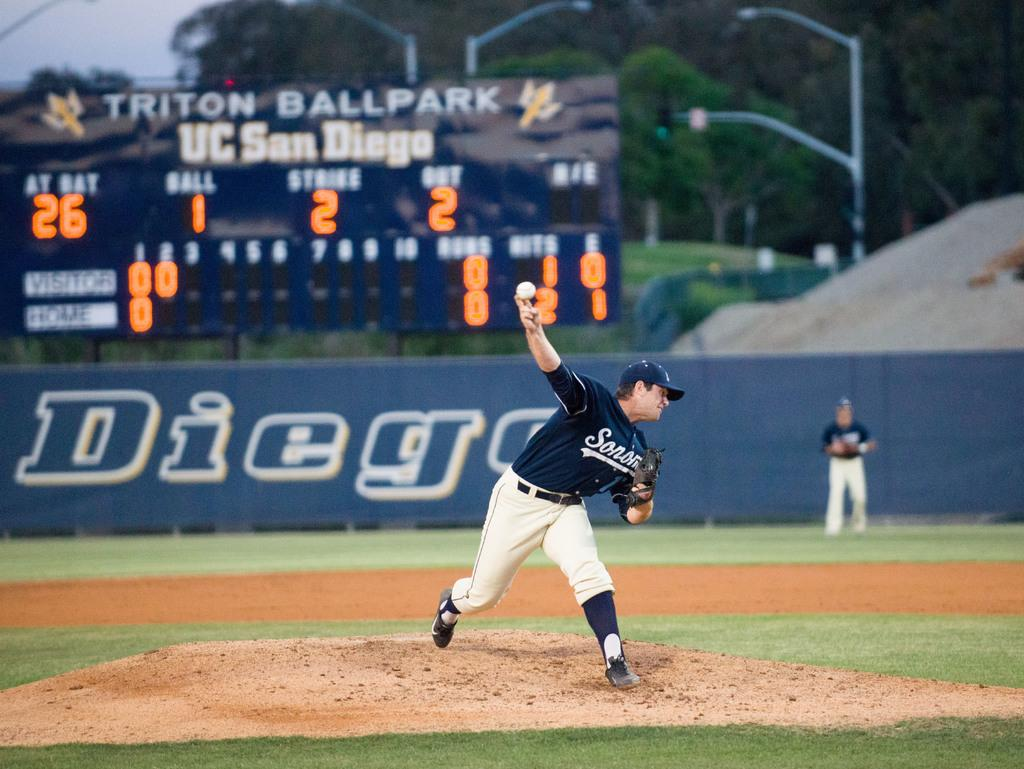Provide a one-sentence caption for the provided image. A baseball game going on at Triton Ballpark at UC San Diego. 